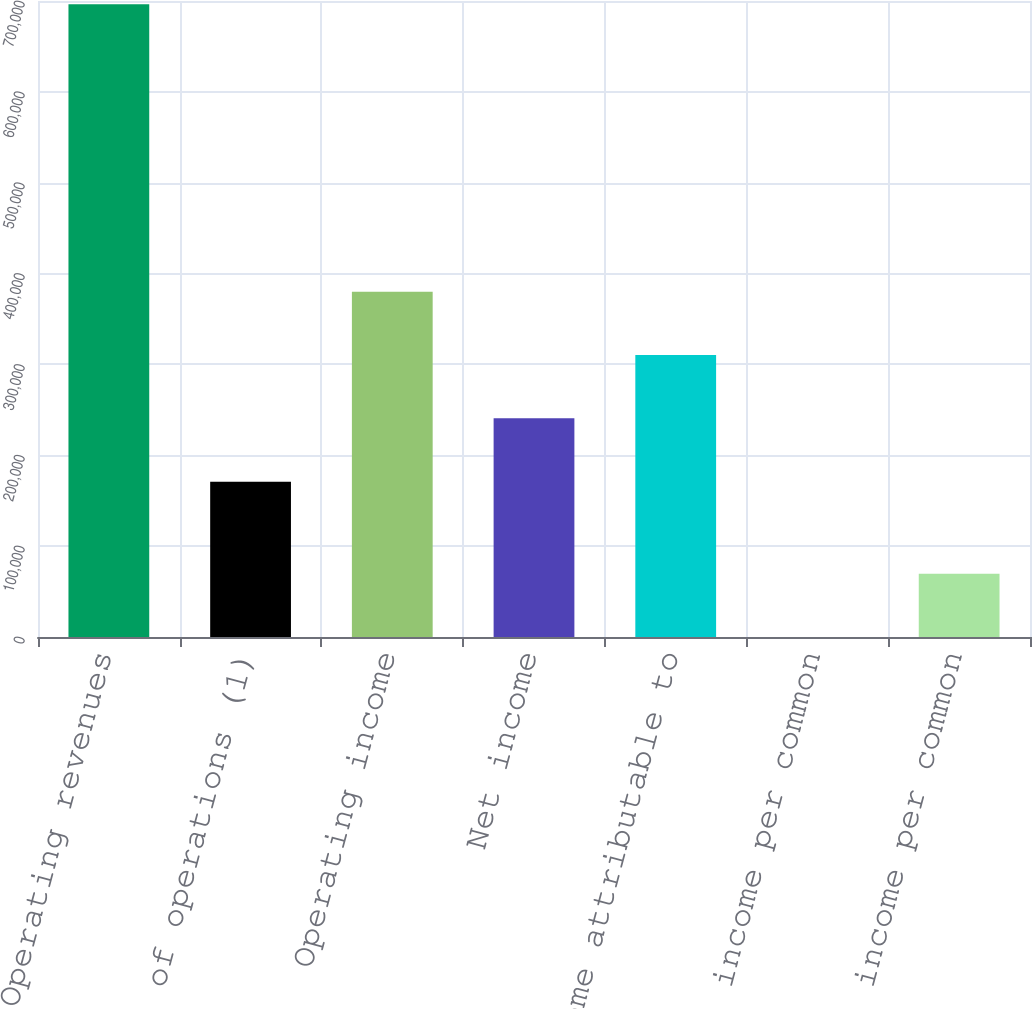Convert chart. <chart><loc_0><loc_0><loc_500><loc_500><bar_chart><fcel>Operating revenues<fcel>Cost of operations (1)<fcel>Operating income<fcel>Net income<fcel>Net income attributable to<fcel>Basic net income per common<fcel>Diluted net income per common<nl><fcel>696517<fcel>170985<fcel>379940<fcel>240637<fcel>310288<fcel>0.56<fcel>69652.2<nl></chart> 